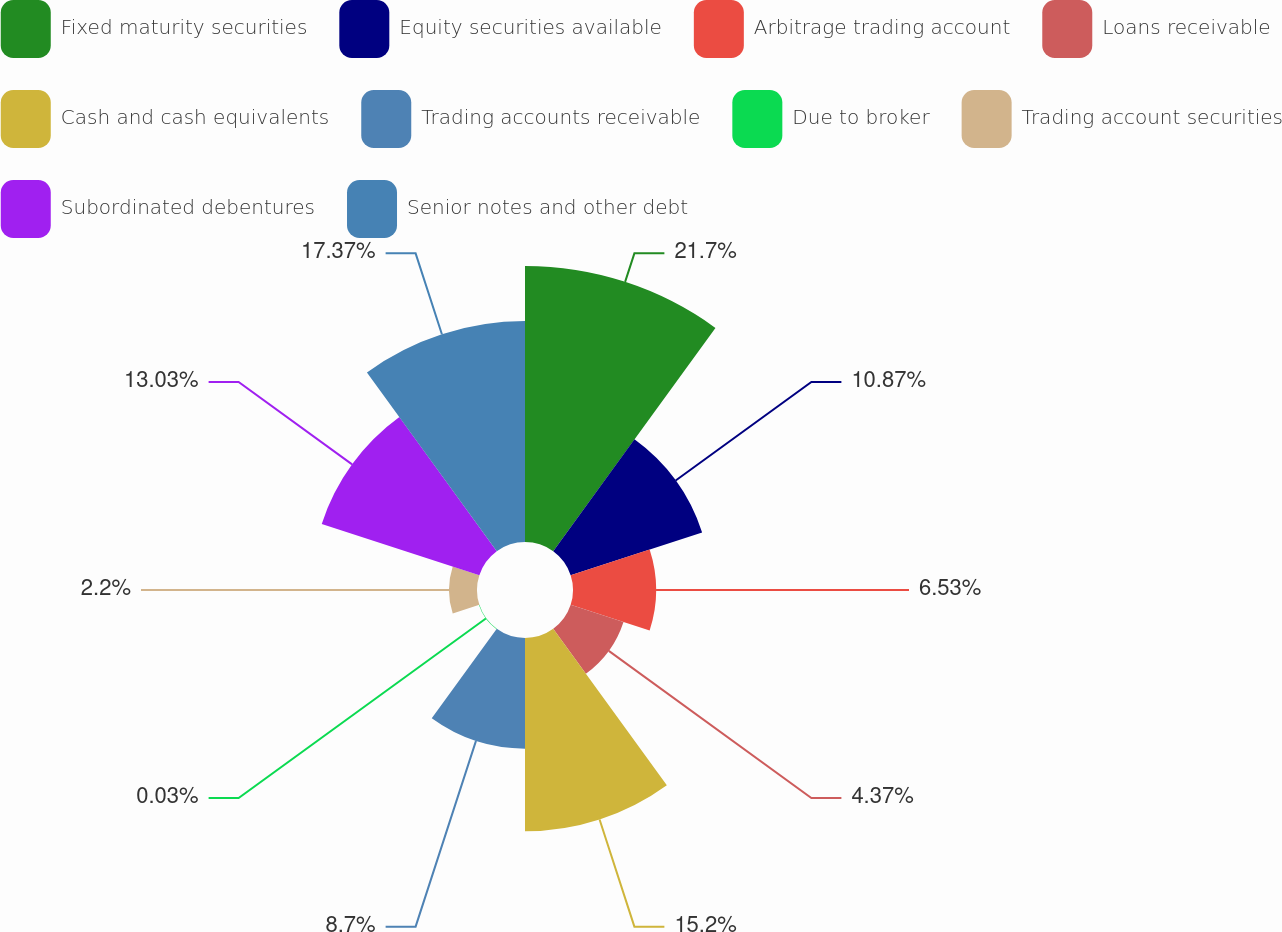<chart> <loc_0><loc_0><loc_500><loc_500><pie_chart><fcel>Fixed maturity securities<fcel>Equity securities available<fcel>Arbitrage trading account<fcel>Loans receivable<fcel>Cash and cash equivalents<fcel>Trading accounts receivable<fcel>Due to broker<fcel>Trading account securities<fcel>Subordinated debentures<fcel>Senior notes and other debt<nl><fcel>21.7%<fcel>10.87%<fcel>6.53%<fcel>4.37%<fcel>15.2%<fcel>8.7%<fcel>0.03%<fcel>2.2%<fcel>13.03%<fcel>17.37%<nl></chart> 